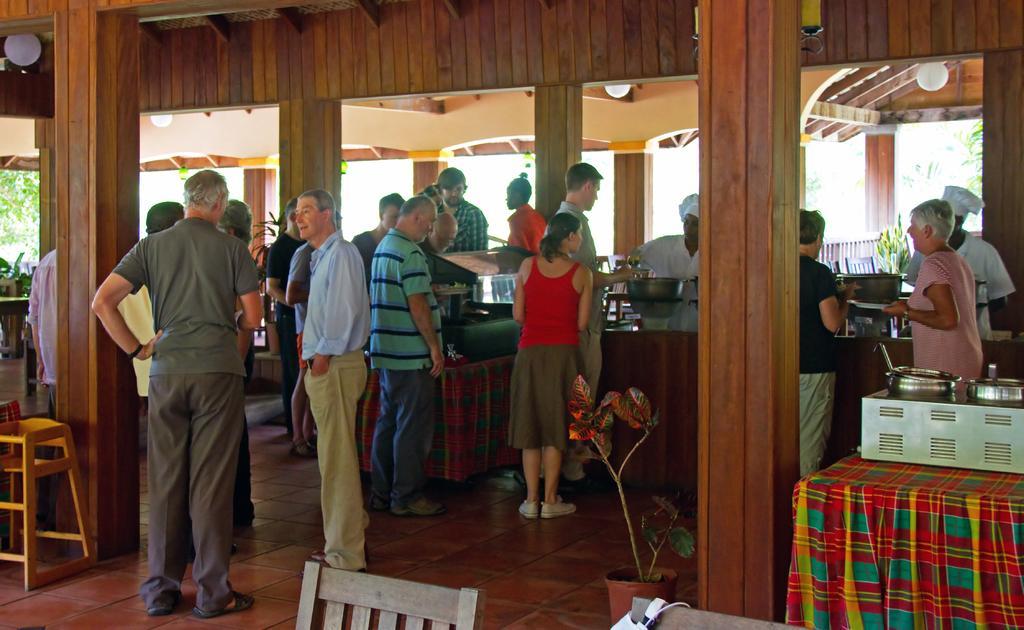Could you give a brief overview of what you see in this image? In this picture we can see a group of people on the floor, here we can see a houseplant, bowls, stool, pillars and some objects and in the background we can see trees, plants. 